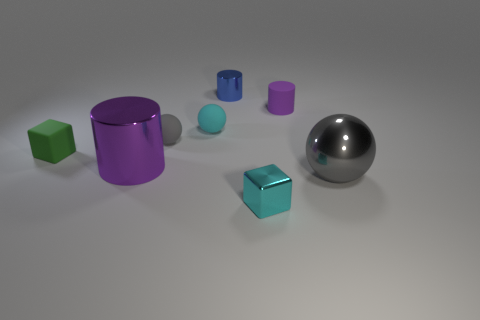Add 2 rubber cylinders. How many objects exist? 10 Subtract all spheres. How many objects are left? 5 Subtract 0 brown cylinders. How many objects are left? 8 Subtract all tiny purple things. Subtract all tiny spheres. How many objects are left? 5 Add 2 small gray balls. How many small gray balls are left? 3 Add 7 small purple metallic things. How many small purple metallic things exist? 7 